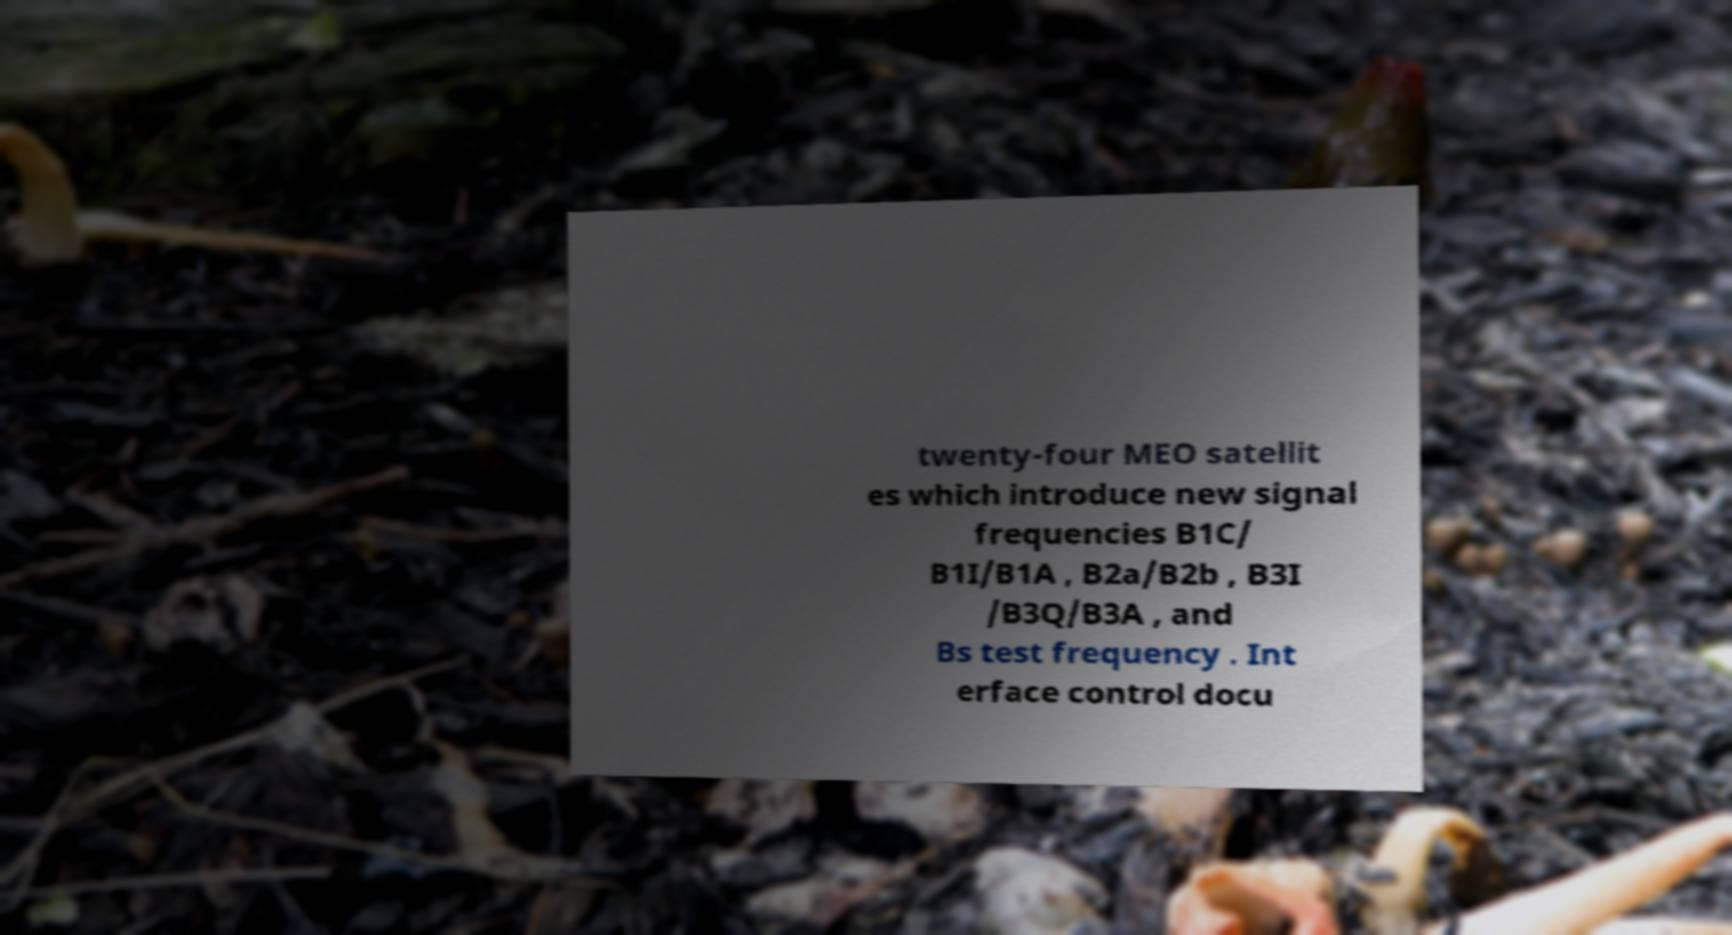Can you read and provide the text displayed in the image?This photo seems to have some interesting text. Can you extract and type it out for me? twenty-four MEO satellit es which introduce new signal frequencies B1C/ B1I/B1A , B2a/B2b , B3I /B3Q/B3A , and Bs test frequency . Int erface control docu 